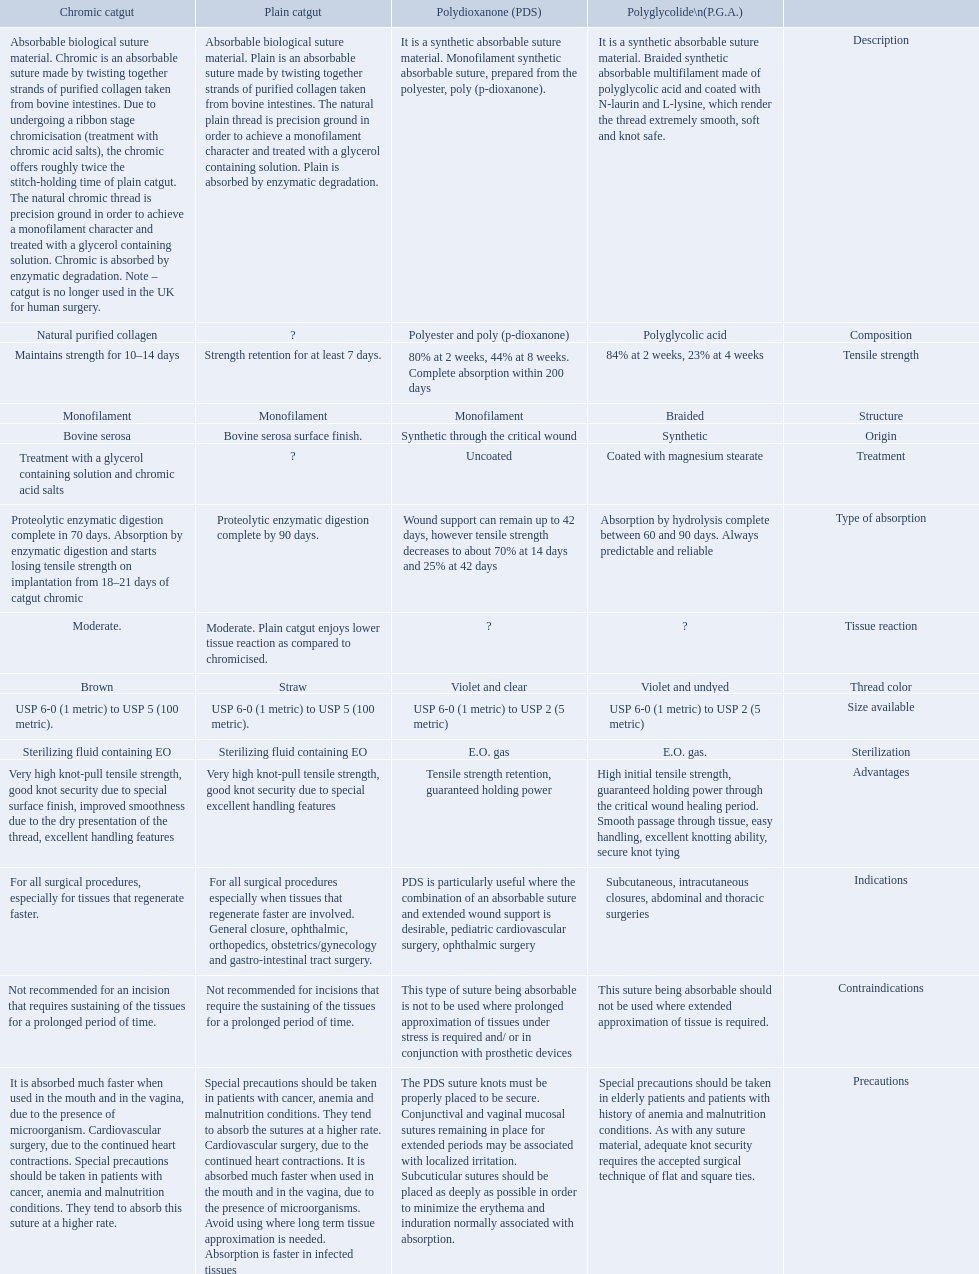Which are the different tensile strengths of the suture materials in the comparison chart? Strength retention for at least 7 days., Maintains strength for 10–14 days, 84% at 2 weeks, 23% at 4 weeks, 80% at 2 weeks, 44% at 8 weeks. Complete absorption within 200 days. Of these, which belongs to plain catgut? Strength retention for at least 7 days. 